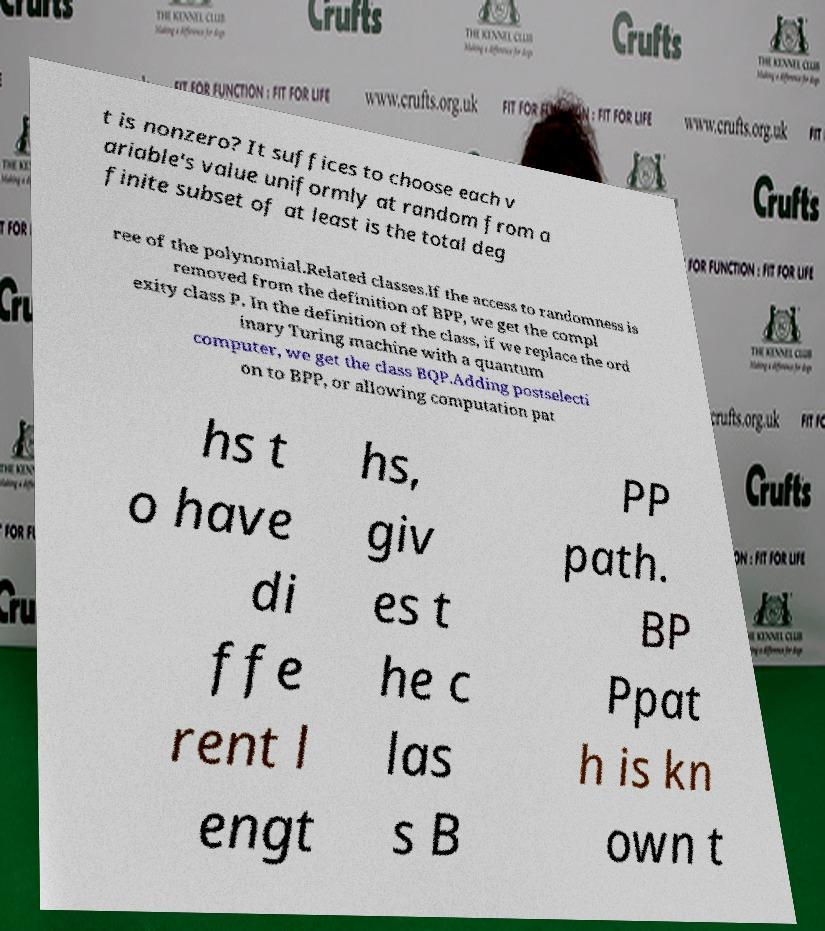What messages or text are displayed in this image? I need them in a readable, typed format. t is nonzero? It suffices to choose each v ariable's value uniformly at random from a finite subset of at least is the total deg ree of the polynomial.Related classes.If the access to randomness is removed from the definition of BPP, we get the compl exity class P. In the definition of the class, if we replace the ord inary Turing machine with a quantum computer, we get the class BQP.Adding postselecti on to BPP, or allowing computation pat hs t o have di ffe rent l engt hs, giv es t he c las s B PP path. BP Ppat h is kn own t 